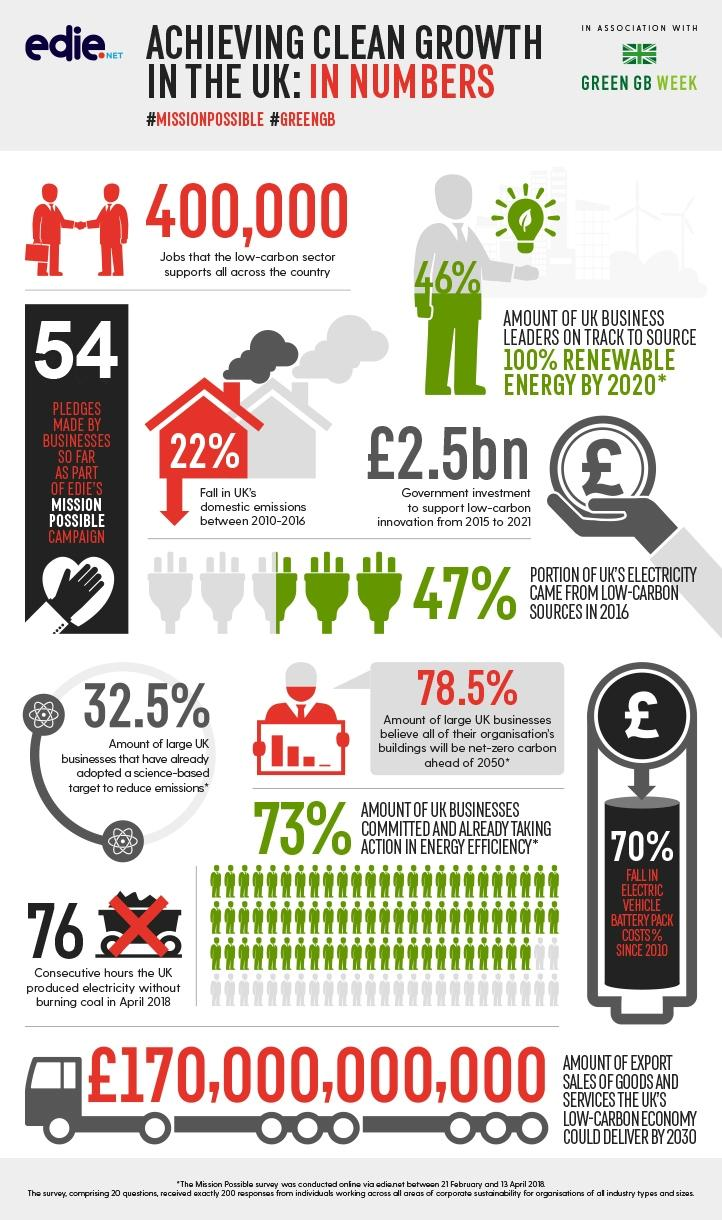Point out several critical features in this image. Electric vehicle battery costs have decreased by 70%. The target to reduce emissions has been adopted by 32.5% of large businesses. A survey of business leaders showed that 46% of them were ready to source 100% of their energy from renewable sources by 2020. According to recent data, domestic emissions have decreased by 22%. 